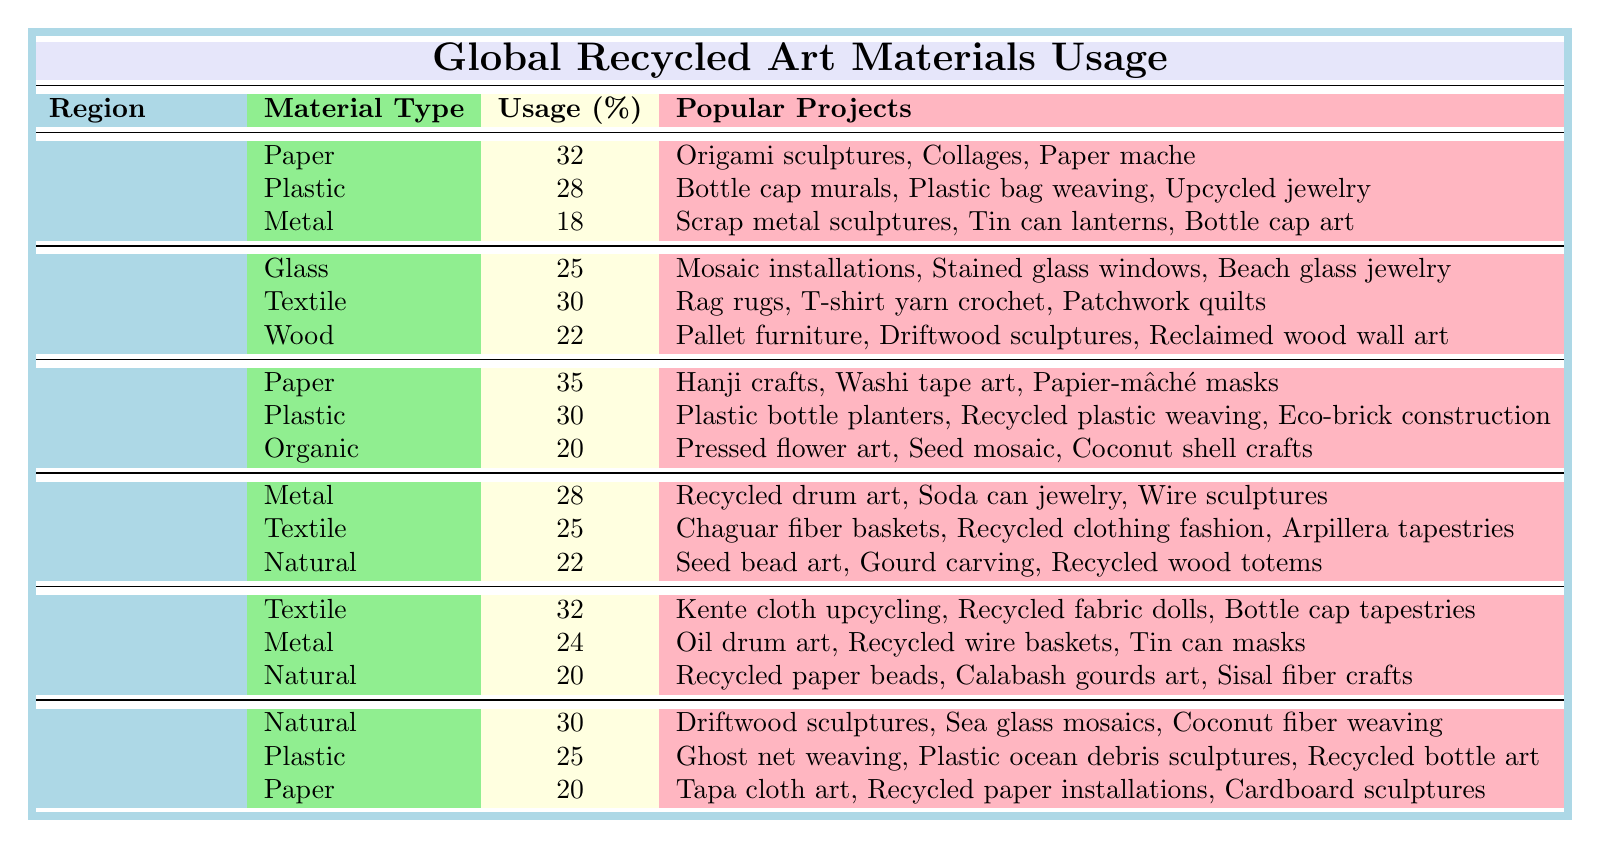What is the most used recycled material type in Asia? In Asia, the material with the highest usage percentage is Paper, at 35%. This is the only material listed for Asia that has a usage over 30%.
Answer: Paper Which region has the highest usage of metal as a recycled material? In South America, the usage of Metal is 28%, which is the highest percentage of usage of Metal among all regions listed.
Answer: South America What percentage of textile usage does Africa have compared to Europe? Africa has 32% usage of Textile, while Europe has 30%. To find the difference: 32% - 30% = 2% more in Africa.
Answer: Africa has 2% more What are the top three materials used in North America? The top three materials in North America, based on usage percentages, are Paper (32%), Plastic (28%), and Metal (18%).
Answer: Paper, Plastic, Metal Is the usage of Natural materials higher in Oceania than in Africa? In Oceania, Natural materials have a usage of 30%, while in Africa, it is 20%. Since 30% is greater than 20%, the statement is true.
Answer: Yes What is the average usage percentage of textile materials across all regions? The textile material percentages are as follows: 30% in Europe, 25% in South America, and 32% in Africa. The average is (30 + 25 + 32) / 3 = 29%
Answer: 29% Which region uses the least percentage of metal? In North America, the usage of Metal is 18%, which is lower than the percentages in other regions that include metal usage.
Answer: North America If you combine the usage of all Paper materials in all regions, what is the total percentage? The Paper material percentages in different regions are: 32% (North America), 0% (Europe has no Paper listed), 35% (Asia), 0% (South America has no Paper), 0% (Africa has no Paper), and 20% (Oceania). 32 + 0 + 35 + 0 + 0 + 20 = 87%.
Answer: 87% What popular project corresponds with the highest material usage type in Asia? The highest material usage in Asia is Paper (35%), which corresponds to the popular projects of Hanji crafts, Washi tape art, and Papier-mâché masks.
Answer: Hanji crafts, Washi tape art, Papier-mâché masks Which two regions have the same usage percentage for Natural materials? In both South America and Africa, the usage percentage for Natural materials is 22%. This means both regions share the same percentage for this material type.
Answer: 22% 